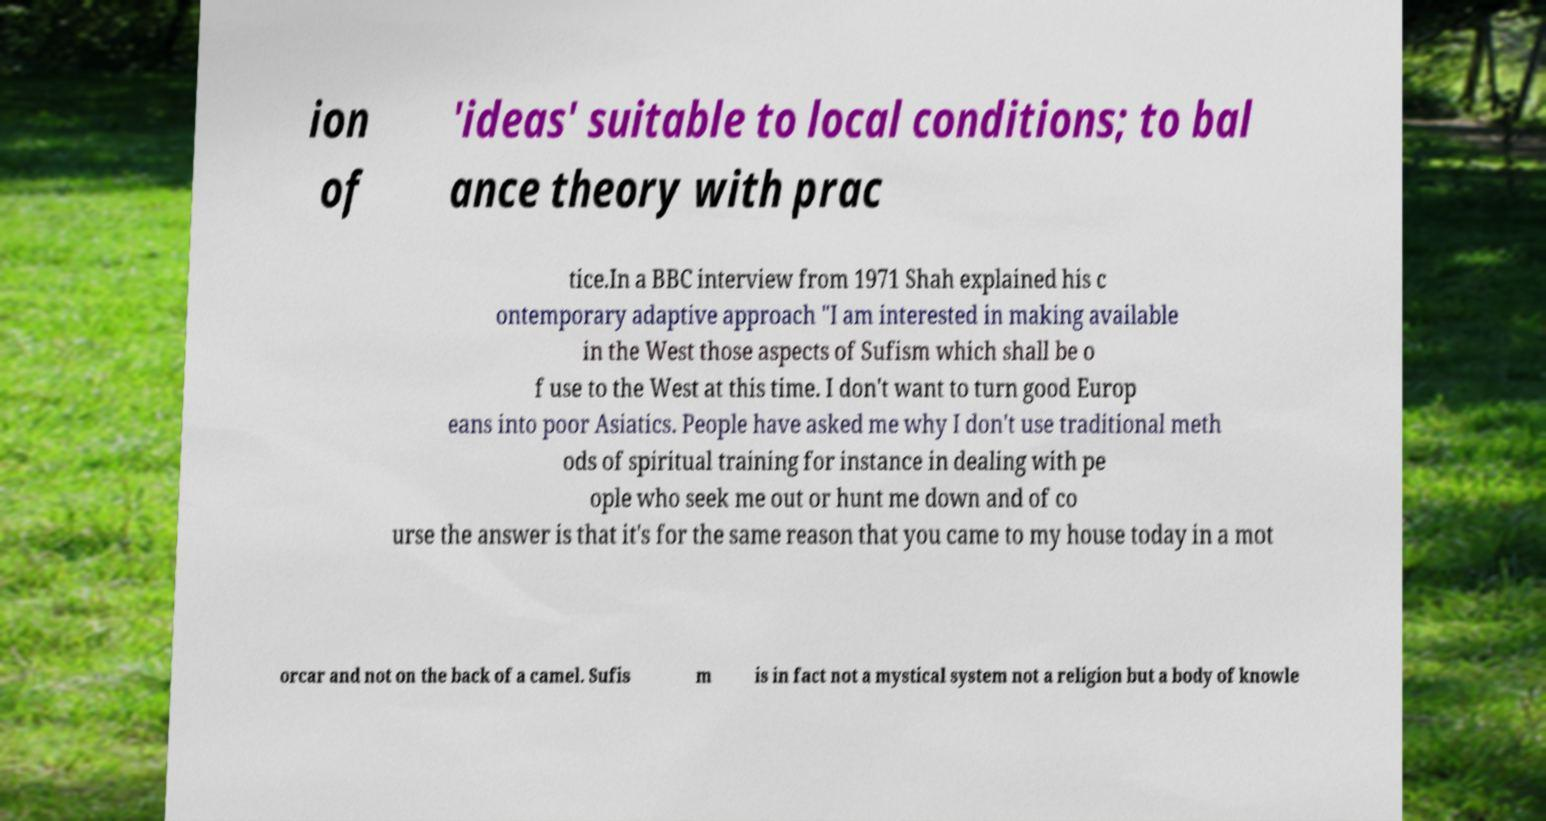Can you accurately transcribe the text from the provided image for me? ion of 'ideas' suitable to local conditions; to bal ance theory with prac tice.In a BBC interview from 1971 Shah explained his c ontemporary adaptive approach "I am interested in making available in the West those aspects of Sufism which shall be o f use to the West at this time. I don't want to turn good Europ eans into poor Asiatics. People have asked me why I don't use traditional meth ods of spiritual training for instance in dealing with pe ople who seek me out or hunt me down and of co urse the answer is that it's for the same reason that you came to my house today in a mot orcar and not on the back of a camel. Sufis m is in fact not a mystical system not a religion but a body of knowle 